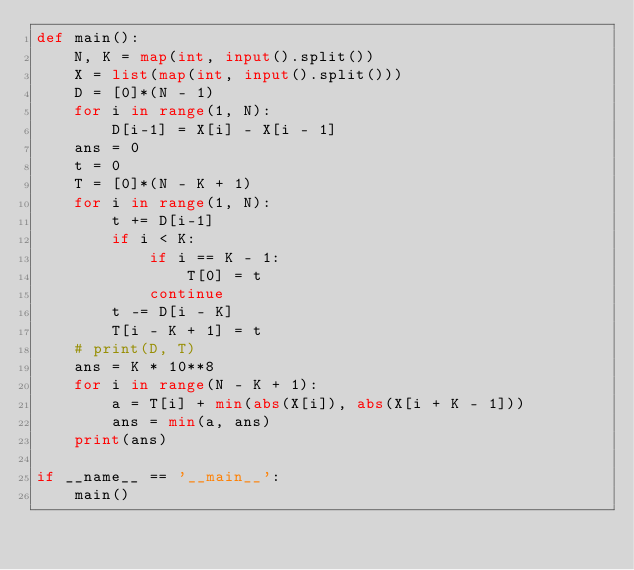<code> <loc_0><loc_0><loc_500><loc_500><_Python_>def main():
    N, K = map(int, input().split())
    X = list(map(int, input().split()))
    D = [0]*(N - 1)
    for i in range(1, N):
        D[i-1] = X[i] - X[i - 1]
    ans = 0
    t = 0
    T = [0]*(N - K + 1)
    for i in range(1, N):
        t += D[i-1]
        if i < K:
            if i == K - 1:
                T[0] = t
            continue
        t -= D[i - K]
        T[i - K + 1] = t
    # print(D, T)
    ans = K * 10**8
    for i in range(N - K + 1):
        a = T[i] + min(abs(X[i]), abs(X[i + K - 1]))
        ans = min(a, ans)
    print(ans)

if __name__ == '__main__':
    main()
</code> 